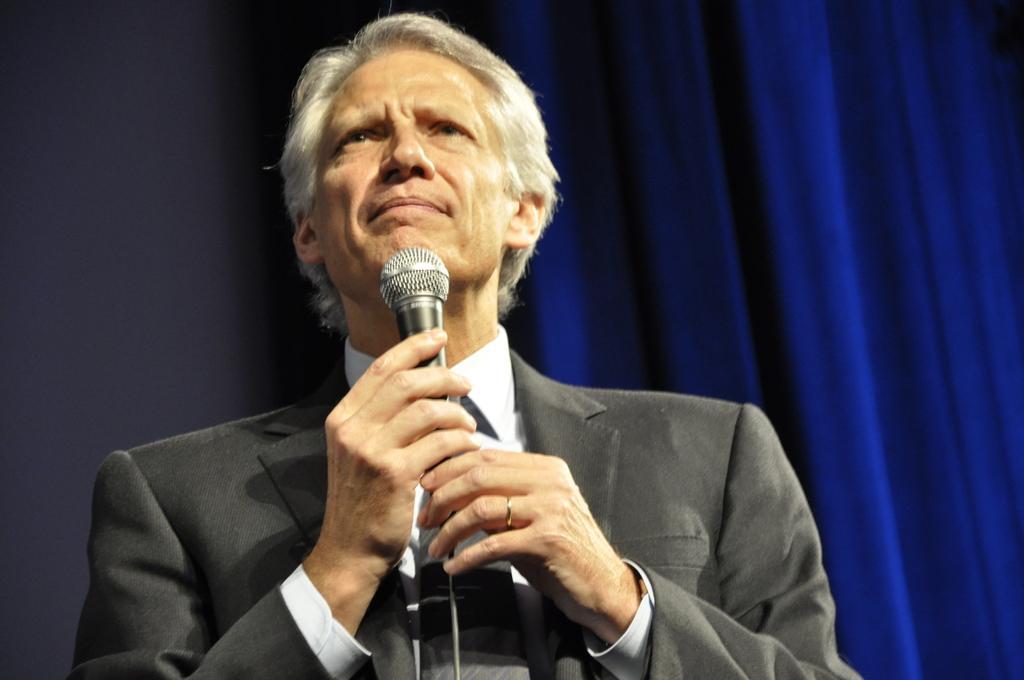How would you summarize this image in a sentence or two? In this picture there is a person wearing suit and holding a mic in his hands and the background is in blue color. 